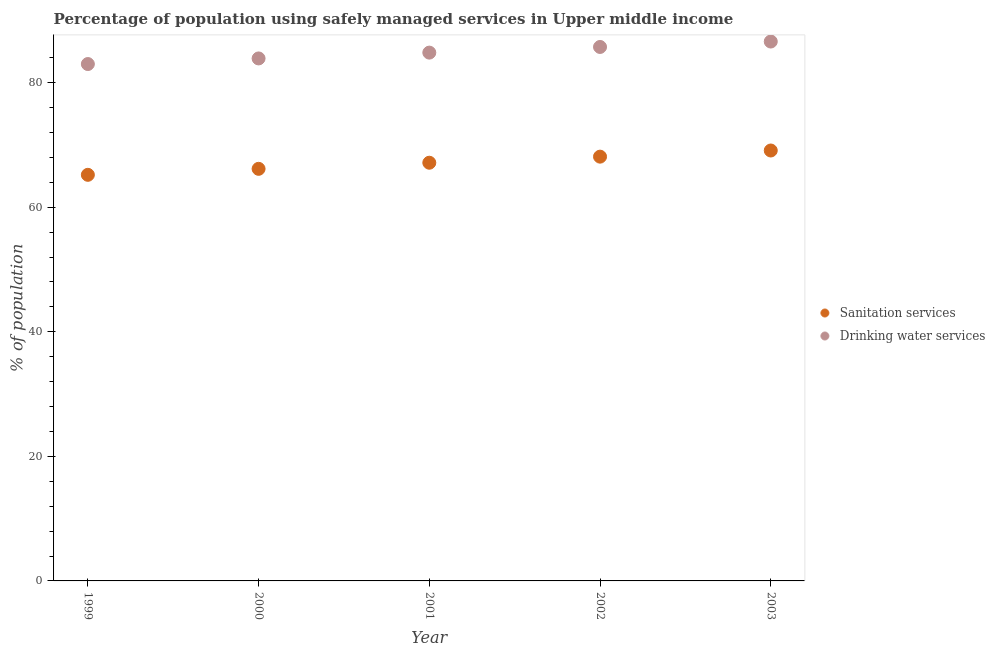How many different coloured dotlines are there?
Give a very brief answer. 2. Is the number of dotlines equal to the number of legend labels?
Provide a succinct answer. Yes. What is the percentage of population who used sanitation services in 2003?
Offer a very short reply. 69.11. Across all years, what is the maximum percentage of population who used drinking water services?
Offer a very short reply. 86.61. Across all years, what is the minimum percentage of population who used sanitation services?
Offer a very short reply. 65.21. In which year was the percentage of population who used sanitation services maximum?
Make the answer very short. 2003. What is the total percentage of population who used sanitation services in the graph?
Provide a succinct answer. 335.76. What is the difference between the percentage of population who used sanitation services in 2000 and that in 2001?
Your answer should be very brief. -0.98. What is the difference between the percentage of population who used drinking water services in 2003 and the percentage of population who used sanitation services in 1999?
Provide a short and direct response. 21.4. What is the average percentage of population who used sanitation services per year?
Give a very brief answer. 67.15. In the year 2002, what is the difference between the percentage of population who used drinking water services and percentage of population who used sanitation services?
Your answer should be very brief. 17.61. In how many years, is the percentage of population who used drinking water services greater than 68 %?
Ensure brevity in your answer.  5. What is the ratio of the percentage of population who used sanitation services in 1999 to that in 2001?
Your answer should be compact. 0.97. Is the difference between the percentage of population who used drinking water services in 2001 and 2002 greater than the difference between the percentage of population who used sanitation services in 2001 and 2002?
Offer a terse response. Yes. What is the difference between the highest and the second highest percentage of population who used drinking water services?
Provide a succinct answer. 0.87. What is the difference between the highest and the lowest percentage of population who used drinking water services?
Your answer should be compact. 3.61. In how many years, is the percentage of population who used drinking water services greater than the average percentage of population who used drinking water services taken over all years?
Your answer should be very brief. 3. Is the sum of the percentage of population who used sanitation services in 1999 and 2002 greater than the maximum percentage of population who used drinking water services across all years?
Offer a very short reply. Yes. Does the percentage of population who used sanitation services monotonically increase over the years?
Provide a short and direct response. Yes. How many years are there in the graph?
Provide a short and direct response. 5. Are the values on the major ticks of Y-axis written in scientific E-notation?
Keep it short and to the point. No. Does the graph contain grids?
Provide a short and direct response. No. Where does the legend appear in the graph?
Give a very brief answer. Center right. How are the legend labels stacked?
Provide a short and direct response. Vertical. What is the title of the graph?
Make the answer very short. Percentage of population using safely managed services in Upper middle income. What is the label or title of the Y-axis?
Provide a short and direct response. % of population. What is the % of population in Sanitation services in 1999?
Keep it short and to the point. 65.21. What is the % of population of Drinking water services in 1999?
Ensure brevity in your answer.  82.99. What is the % of population of Sanitation services in 2000?
Provide a short and direct response. 66.17. What is the % of population in Drinking water services in 2000?
Offer a terse response. 83.89. What is the % of population of Sanitation services in 2001?
Ensure brevity in your answer.  67.15. What is the % of population of Drinking water services in 2001?
Keep it short and to the point. 84.83. What is the % of population of Sanitation services in 2002?
Ensure brevity in your answer.  68.12. What is the % of population of Drinking water services in 2002?
Offer a terse response. 85.74. What is the % of population in Sanitation services in 2003?
Give a very brief answer. 69.11. What is the % of population of Drinking water services in 2003?
Offer a terse response. 86.61. Across all years, what is the maximum % of population of Sanitation services?
Your response must be concise. 69.11. Across all years, what is the maximum % of population in Drinking water services?
Provide a succinct answer. 86.61. Across all years, what is the minimum % of population of Sanitation services?
Ensure brevity in your answer.  65.21. Across all years, what is the minimum % of population of Drinking water services?
Provide a succinct answer. 82.99. What is the total % of population in Sanitation services in the graph?
Your answer should be very brief. 335.76. What is the total % of population in Drinking water services in the graph?
Provide a short and direct response. 424.06. What is the difference between the % of population in Sanitation services in 1999 and that in 2000?
Provide a short and direct response. -0.96. What is the difference between the % of population in Drinking water services in 1999 and that in 2000?
Make the answer very short. -0.9. What is the difference between the % of population of Sanitation services in 1999 and that in 2001?
Offer a very short reply. -1.94. What is the difference between the % of population in Drinking water services in 1999 and that in 2001?
Ensure brevity in your answer.  -1.83. What is the difference between the % of population of Sanitation services in 1999 and that in 2002?
Your answer should be very brief. -2.92. What is the difference between the % of population of Drinking water services in 1999 and that in 2002?
Provide a short and direct response. -2.74. What is the difference between the % of population of Sanitation services in 1999 and that in 2003?
Your answer should be very brief. -3.9. What is the difference between the % of population of Drinking water services in 1999 and that in 2003?
Make the answer very short. -3.61. What is the difference between the % of population of Sanitation services in 2000 and that in 2001?
Your response must be concise. -0.98. What is the difference between the % of population in Drinking water services in 2000 and that in 2001?
Offer a terse response. -0.93. What is the difference between the % of population in Sanitation services in 2000 and that in 2002?
Keep it short and to the point. -1.96. What is the difference between the % of population in Drinking water services in 2000 and that in 2002?
Ensure brevity in your answer.  -1.84. What is the difference between the % of population of Sanitation services in 2000 and that in 2003?
Provide a short and direct response. -2.94. What is the difference between the % of population in Drinking water services in 2000 and that in 2003?
Give a very brief answer. -2.71. What is the difference between the % of population in Sanitation services in 2001 and that in 2002?
Make the answer very short. -0.98. What is the difference between the % of population of Drinking water services in 2001 and that in 2002?
Make the answer very short. -0.91. What is the difference between the % of population in Sanitation services in 2001 and that in 2003?
Give a very brief answer. -1.96. What is the difference between the % of population in Drinking water services in 2001 and that in 2003?
Your answer should be compact. -1.78. What is the difference between the % of population in Sanitation services in 2002 and that in 2003?
Your answer should be very brief. -0.99. What is the difference between the % of population in Drinking water services in 2002 and that in 2003?
Make the answer very short. -0.87. What is the difference between the % of population in Sanitation services in 1999 and the % of population in Drinking water services in 2000?
Offer a terse response. -18.69. What is the difference between the % of population of Sanitation services in 1999 and the % of population of Drinking water services in 2001?
Make the answer very short. -19.62. What is the difference between the % of population of Sanitation services in 1999 and the % of population of Drinking water services in 2002?
Your answer should be compact. -20.53. What is the difference between the % of population of Sanitation services in 1999 and the % of population of Drinking water services in 2003?
Offer a terse response. -21.4. What is the difference between the % of population in Sanitation services in 2000 and the % of population in Drinking water services in 2001?
Provide a short and direct response. -18.66. What is the difference between the % of population in Sanitation services in 2000 and the % of population in Drinking water services in 2002?
Give a very brief answer. -19.57. What is the difference between the % of population of Sanitation services in 2000 and the % of population of Drinking water services in 2003?
Your answer should be very brief. -20.44. What is the difference between the % of population in Sanitation services in 2001 and the % of population in Drinking water services in 2002?
Your answer should be very brief. -18.59. What is the difference between the % of population of Sanitation services in 2001 and the % of population of Drinking water services in 2003?
Provide a short and direct response. -19.46. What is the difference between the % of population of Sanitation services in 2002 and the % of population of Drinking water services in 2003?
Offer a very short reply. -18.48. What is the average % of population in Sanitation services per year?
Give a very brief answer. 67.15. What is the average % of population in Drinking water services per year?
Your answer should be compact. 84.81. In the year 1999, what is the difference between the % of population in Sanitation services and % of population in Drinking water services?
Give a very brief answer. -17.79. In the year 2000, what is the difference between the % of population of Sanitation services and % of population of Drinking water services?
Give a very brief answer. -17.73. In the year 2001, what is the difference between the % of population in Sanitation services and % of population in Drinking water services?
Offer a terse response. -17.68. In the year 2002, what is the difference between the % of population of Sanitation services and % of population of Drinking water services?
Give a very brief answer. -17.61. In the year 2003, what is the difference between the % of population in Sanitation services and % of population in Drinking water services?
Ensure brevity in your answer.  -17.5. What is the ratio of the % of population of Sanitation services in 1999 to that in 2000?
Give a very brief answer. 0.99. What is the ratio of the % of population of Drinking water services in 1999 to that in 2000?
Make the answer very short. 0.99. What is the ratio of the % of population of Sanitation services in 1999 to that in 2001?
Provide a short and direct response. 0.97. What is the ratio of the % of population of Drinking water services in 1999 to that in 2001?
Offer a very short reply. 0.98. What is the ratio of the % of population of Sanitation services in 1999 to that in 2002?
Provide a succinct answer. 0.96. What is the ratio of the % of population of Drinking water services in 1999 to that in 2002?
Provide a short and direct response. 0.97. What is the ratio of the % of population in Sanitation services in 1999 to that in 2003?
Your answer should be compact. 0.94. What is the ratio of the % of population in Drinking water services in 1999 to that in 2003?
Make the answer very short. 0.96. What is the ratio of the % of population of Sanitation services in 2000 to that in 2001?
Ensure brevity in your answer.  0.99. What is the ratio of the % of population in Sanitation services in 2000 to that in 2002?
Keep it short and to the point. 0.97. What is the ratio of the % of population in Drinking water services in 2000 to that in 2002?
Provide a short and direct response. 0.98. What is the ratio of the % of population of Sanitation services in 2000 to that in 2003?
Ensure brevity in your answer.  0.96. What is the ratio of the % of population of Drinking water services in 2000 to that in 2003?
Your answer should be compact. 0.97. What is the ratio of the % of population in Sanitation services in 2001 to that in 2002?
Your answer should be very brief. 0.99. What is the ratio of the % of population of Drinking water services in 2001 to that in 2002?
Your answer should be compact. 0.99. What is the ratio of the % of population in Sanitation services in 2001 to that in 2003?
Make the answer very short. 0.97. What is the ratio of the % of population of Drinking water services in 2001 to that in 2003?
Provide a succinct answer. 0.98. What is the ratio of the % of population of Sanitation services in 2002 to that in 2003?
Provide a short and direct response. 0.99. What is the ratio of the % of population in Drinking water services in 2002 to that in 2003?
Offer a terse response. 0.99. What is the difference between the highest and the second highest % of population in Sanitation services?
Offer a very short reply. 0.99. What is the difference between the highest and the second highest % of population of Drinking water services?
Your answer should be compact. 0.87. What is the difference between the highest and the lowest % of population in Sanitation services?
Your response must be concise. 3.9. What is the difference between the highest and the lowest % of population of Drinking water services?
Offer a terse response. 3.61. 